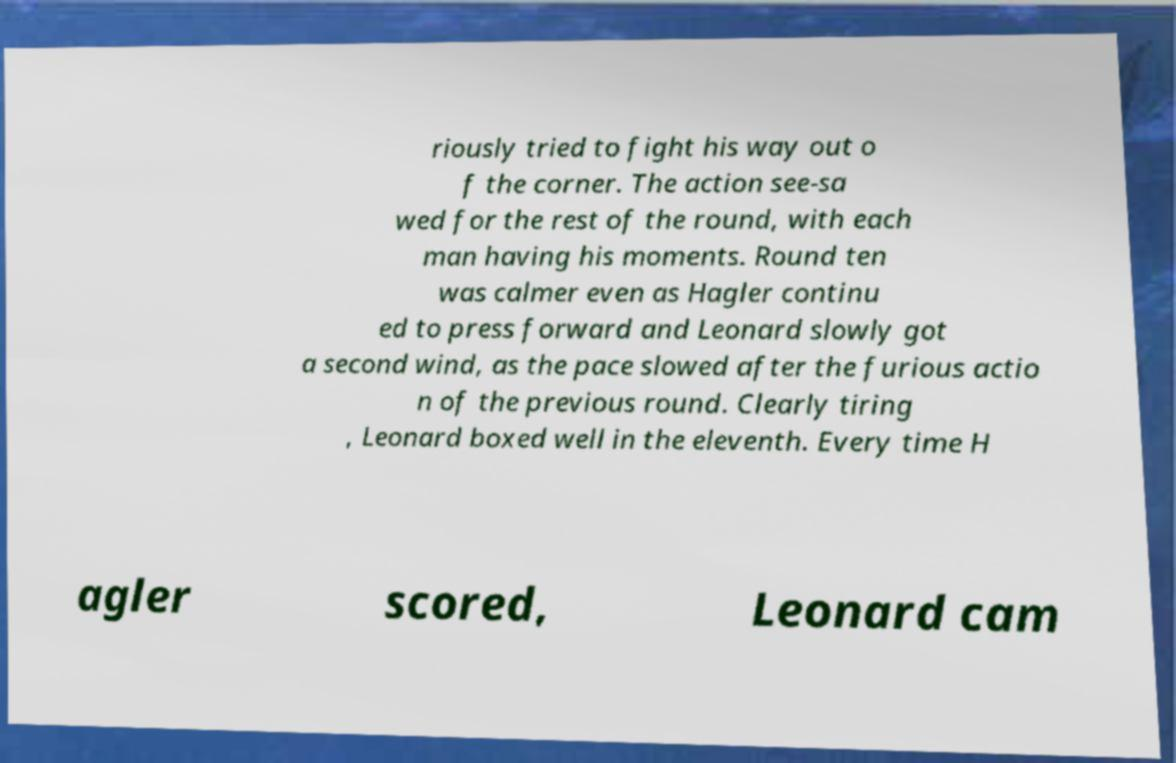There's text embedded in this image that I need extracted. Can you transcribe it verbatim? riously tried to fight his way out o f the corner. The action see-sa wed for the rest of the round, with each man having his moments. Round ten was calmer even as Hagler continu ed to press forward and Leonard slowly got a second wind, as the pace slowed after the furious actio n of the previous round. Clearly tiring , Leonard boxed well in the eleventh. Every time H agler scored, Leonard cam 